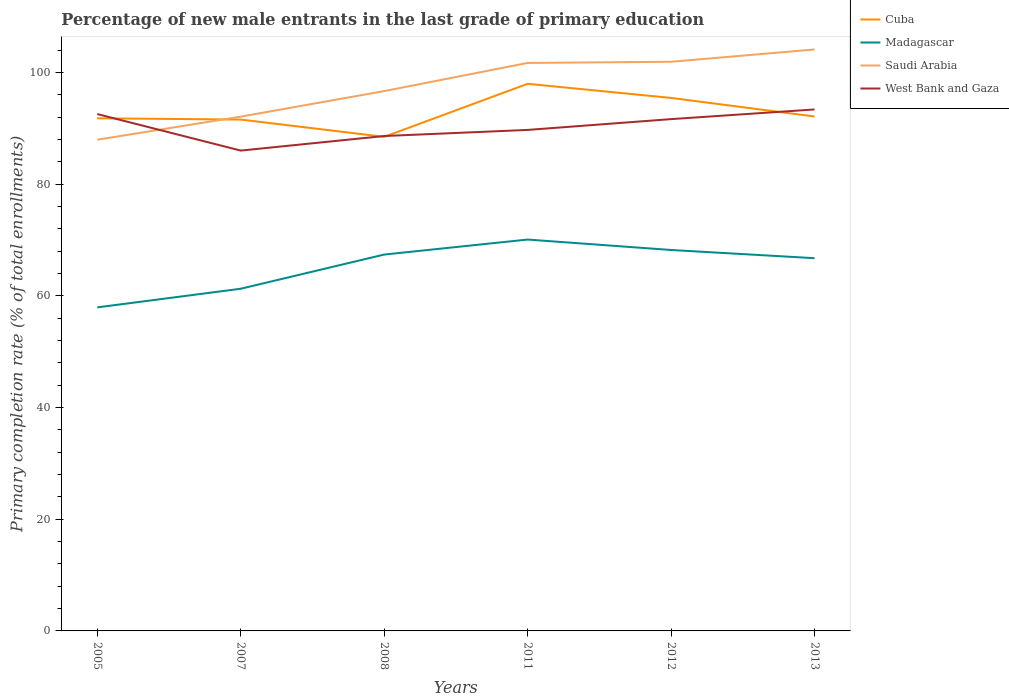Does the line corresponding to Madagascar intersect with the line corresponding to Cuba?
Provide a succinct answer. No. Across all years, what is the maximum percentage of new male entrants in West Bank and Gaza?
Ensure brevity in your answer.  86. In which year was the percentage of new male entrants in Cuba maximum?
Your answer should be very brief. 2008. What is the total percentage of new male entrants in West Bank and Gaza in the graph?
Make the answer very short. -0.83. What is the difference between the highest and the second highest percentage of new male entrants in Saudi Arabia?
Keep it short and to the point. 16.16. What is the difference between two consecutive major ticks on the Y-axis?
Give a very brief answer. 20. Are the values on the major ticks of Y-axis written in scientific E-notation?
Provide a short and direct response. No. Where does the legend appear in the graph?
Make the answer very short. Top right. How are the legend labels stacked?
Keep it short and to the point. Vertical. What is the title of the graph?
Provide a succinct answer. Percentage of new male entrants in the last grade of primary education. What is the label or title of the X-axis?
Your response must be concise. Years. What is the label or title of the Y-axis?
Keep it short and to the point. Primary completion rate (% of total enrollments). What is the Primary completion rate (% of total enrollments) in Cuba in 2005?
Keep it short and to the point. 91.78. What is the Primary completion rate (% of total enrollments) in Madagascar in 2005?
Keep it short and to the point. 57.92. What is the Primary completion rate (% of total enrollments) in Saudi Arabia in 2005?
Offer a terse response. 87.94. What is the Primary completion rate (% of total enrollments) in West Bank and Gaza in 2005?
Give a very brief answer. 92.54. What is the Primary completion rate (% of total enrollments) in Cuba in 2007?
Ensure brevity in your answer.  91.55. What is the Primary completion rate (% of total enrollments) of Madagascar in 2007?
Offer a terse response. 61.26. What is the Primary completion rate (% of total enrollments) in Saudi Arabia in 2007?
Ensure brevity in your answer.  92.07. What is the Primary completion rate (% of total enrollments) in West Bank and Gaza in 2007?
Ensure brevity in your answer.  86. What is the Primary completion rate (% of total enrollments) in Cuba in 2008?
Ensure brevity in your answer.  88.46. What is the Primary completion rate (% of total enrollments) of Madagascar in 2008?
Offer a terse response. 67.38. What is the Primary completion rate (% of total enrollments) in Saudi Arabia in 2008?
Your answer should be very brief. 96.65. What is the Primary completion rate (% of total enrollments) of West Bank and Gaza in 2008?
Make the answer very short. 88.6. What is the Primary completion rate (% of total enrollments) in Cuba in 2011?
Offer a terse response. 97.95. What is the Primary completion rate (% of total enrollments) of Madagascar in 2011?
Your answer should be compact. 70.07. What is the Primary completion rate (% of total enrollments) in Saudi Arabia in 2011?
Provide a short and direct response. 101.69. What is the Primary completion rate (% of total enrollments) of West Bank and Gaza in 2011?
Your answer should be very brief. 89.7. What is the Primary completion rate (% of total enrollments) in Cuba in 2012?
Offer a very short reply. 95.42. What is the Primary completion rate (% of total enrollments) in Madagascar in 2012?
Offer a very short reply. 68.2. What is the Primary completion rate (% of total enrollments) in Saudi Arabia in 2012?
Your answer should be compact. 101.9. What is the Primary completion rate (% of total enrollments) of West Bank and Gaza in 2012?
Your response must be concise. 91.63. What is the Primary completion rate (% of total enrollments) in Cuba in 2013?
Your answer should be very brief. 92.1. What is the Primary completion rate (% of total enrollments) of Madagascar in 2013?
Your response must be concise. 66.73. What is the Primary completion rate (% of total enrollments) in Saudi Arabia in 2013?
Provide a succinct answer. 104.1. What is the Primary completion rate (% of total enrollments) of West Bank and Gaza in 2013?
Your answer should be compact. 93.36. Across all years, what is the maximum Primary completion rate (% of total enrollments) in Cuba?
Provide a short and direct response. 97.95. Across all years, what is the maximum Primary completion rate (% of total enrollments) in Madagascar?
Give a very brief answer. 70.07. Across all years, what is the maximum Primary completion rate (% of total enrollments) in Saudi Arabia?
Keep it short and to the point. 104.1. Across all years, what is the maximum Primary completion rate (% of total enrollments) in West Bank and Gaza?
Your response must be concise. 93.36. Across all years, what is the minimum Primary completion rate (% of total enrollments) of Cuba?
Provide a succinct answer. 88.46. Across all years, what is the minimum Primary completion rate (% of total enrollments) in Madagascar?
Provide a succinct answer. 57.92. Across all years, what is the minimum Primary completion rate (% of total enrollments) in Saudi Arabia?
Keep it short and to the point. 87.94. Across all years, what is the minimum Primary completion rate (% of total enrollments) of West Bank and Gaza?
Provide a short and direct response. 86. What is the total Primary completion rate (% of total enrollments) in Cuba in the graph?
Make the answer very short. 557.26. What is the total Primary completion rate (% of total enrollments) of Madagascar in the graph?
Make the answer very short. 391.57. What is the total Primary completion rate (% of total enrollments) in Saudi Arabia in the graph?
Your answer should be compact. 584.34. What is the total Primary completion rate (% of total enrollments) of West Bank and Gaza in the graph?
Make the answer very short. 541.82. What is the difference between the Primary completion rate (% of total enrollments) of Cuba in 2005 and that in 2007?
Your answer should be very brief. 0.22. What is the difference between the Primary completion rate (% of total enrollments) in Madagascar in 2005 and that in 2007?
Offer a very short reply. -3.34. What is the difference between the Primary completion rate (% of total enrollments) of Saudi Arabia in 2005 and that in 2007?
Give a very brief answer. -4.13. What is the difference between the Primary completion rate (% of total enrollments) of West Bank and Gaza in 2005 and that in 2007?
Offer a terse response. 6.54. What is the difference between the Primary completion rate (% of total enrollments) of Cuba in 2005 and that in 2008?
Ensure brevity in your answer.  3.32. What is the difference between the Primary completion rate (% of total enrollments) of Madagascar in 2005 and that in 2008?
Give a very brief answer. -9.46. What is the difference between the Primary completion rate (% of total enrollments) in Saudi Arabia in 2005 and that in 2008?
Offer a terse response. -8.71. What is the difference between the Primary completion rate (% of total enrollments) of West Bank and Gaza in 2005 and that in 2008?
Ensure brevity in your answer.  3.93. What is the difference between the Primary completion rate (% of total enrollments) in Cuba in 2005 and that in 2011?
Offer a very short reply. -6.18. What is the difference between the Primary completion rate (% of total enrollments) in Madagascar in 2005 and that in 2011?
Make the answer very short. -12.14. What is the difference between the Primary completion rate (% of total enrollments) of Saudi Arabia in 2005 and that in 2011?
Offer a very short reply. -13.75. What is the difference between the Primary completion rate (% of total enrollments) of West Bank and Gaza in 2005 and that in 2011?
Make the answer very short. 2.84. What is the difference between the Primary completion rate (% of total enrollments) in Cuba in 2005 and that in 2012?
Make the answer very short. -3.65. What is the difference between the Primary completion rate (% of total enrollments) of Madagascar in 2005 and that in 2012?
Ensure brevity in your answer.  -10.28. What is the difference between the Primary completion rate (% of total enrollments) of Saudi Arabia in 2005 and that in 2012?
Offer a terse response. -13.96. What is the difference between the Primary completion rate (% of total enrollments) in West Bank and Gaza in 2005 and that in 2012?
Offer a very short reply. 0.91. What is the difference between the Primary completion rate (% of total enrollments) in Cuba in 2005 and that in 2013?
Ensure brevity in your answer.  -0.32. What is the difference between the Primary completion rate (% of total enrollments) of Madagascar in 2005 and that in 2013?
Provide a short and direct response. -8.81. What is the difference between the Primary completion rate (% of total enrollments) in Saudi Arabia in 2005 and that in 2013?
Make the answer very short. -16.16. What is the difference between the Primary completion rate (% of total enrollments) of West Bank and Gaza in 2005 and that in 2013?
Make the answer very short. -0.83. What is the difference between the Primary completion rate (% of total enrollments) of Cuba in 2007 and that in 2008?
Give a very brief answer. 3.09. What is the difference between the Primary completion rate (% of total enrollments) in Madagascar in 2007 and that in 2008?
Your response must be concise. -6.12. What is the difference between the Primary completion rate (% of total enrollments) of Saudi Arabia in 2007 and that in 2008?
Give a very brief answer. -4.57. What is the difference between the Primary completion rate (% of total enrollments) of West Bank and Gaza in 2007 and that in 2008?
Ensure brevity in your answer.  -2.61. What is the difference between the Primary completion rate (% of total enrollments) of Cuba in 2007 and that in 2011?
Your response must be concise. -6.4. What is the difference between the Primary completion rate (% of total enrollments) of Madagascar in 2007 and that in 2011?
Provide a succinct answer. -8.8. What is the difference between the Primary completion rate (% of total enrollments) of Saudi Arabia in 2007 and that in 2011?
Your answer should be compact. -9.61. What is the difference between the Primary completion rate (% of total enrollments) in West Bank and Gaza in 2007 and that in 2011?
Provide a short and direct response. -3.7. What is the difference between the Primary completion rate (% of total enrollments) of Cuba in 2007 and that in 2012?
Provide a short and direct response. -3.87. What is the difference between the Primary completion rate (% of total enrollments) of Madagascar in 2007 and that in 2012?
Provide a succinct answer. -6.94. What is the difference between the Primary completion rate (% of total enrollments) in Saudi Arabia in 2007 and that in 2012?
Your answer should be very brief. -9.82. What is the difference between the Primary completion rate (% of total enrollments) in West Bank and Gaza in 2007 and that in 2012?
Offer a very short reply. -5.63. What is the difference between the Primary completion rate (% of total enrollments) of Cuba in 2007 and that in 2013?
Provide a succinct answer. -0.55. What is the difference between the Primary completion rate (% of total enrollments) in Madagascar in 2007 and that in 2013?
Your answer should be compact. -5.47. What is the difference between the Primary completion rate (% of total enrollments) of Saudi Arabia in 2007 and that in 2013?
Make the answer very short. -12.03. What is the difference between the Primary completion rate (% of total enrollments) in West Bank and Gaza in 2007 and that in 2013?
Keep it short and to the point. -7.36. What is the difference between the Primary completion rate (% of total enrollments) of Cuba in 2008 and that in 2011?
Offer a terse response. -9.5. What is the difference between the Primary completion rate (% of total enrollments) in Madagascar in 2008 and that in 2011?
Provide a succinct answer. -2.69. What is the difference between the Primary completion rate (% of total enrollments) in Saudi Arabia in 2008 and that in 2011?
Provide a short and direct response. -5.04. What is the difference between the Primary completion rate (% of total enrollments) in West Bank and Gaza in 2008 and that in 2011?
Your answer should be very brief. -1.09. What is the difference between the Primary completion rate (% of total enrollments) in Cuba in 2008 and that in 2012?
Give a very brief answer. -6.97. What is the difference between the Primary completion rate (% of total enrollments) of Madagascar in 2008 and that in 2012?
Your answer should be compact. -0.82. What is the difference between the Primary completion rate (% of total enrollments) in Saudi Arabia in 2008 and that in 2012?
Provide a short and direct response. -5.25. What is the difference between the Primary completion rate (% of total enrollments) in West Bank and Gaza in 2008 and that in 2012?
Provide a short and direct response. -3.03. What is the difference between the Primary completion rate (% of total enrollments) of Cuba in 2008 and that in 2013?
Offer a terse response. -3.64. What is the difference between the Primary completion rate (% of total enrollments) in Madagascar in 2008 and that in 2013?
Offer a very short reply. 0.65. What is the difference between the Primary completion rate (% of total enrollments) in Saudi Arabia in 2008 and that in 2013?
Offer a very short reply. -7.45. What is the difference between the Primary completion rate (% of total enrollments) in West Bank and Gaza in 2008 and that in 2013?
Your response must be concise. -4.76. What is the difference between the Primary completion rate (% of total enrollments) of Cuba in 2011 and that in 2012?
Your answer should be compact. 2.53. What is the difference between the Primary completion rate (% of total enrollments) in Madagascar in 2011 and that in 2012?
Ensure brevity in your answer.  1.87. What is the difference between the Primary completion rate (% of total enrollments) of Saudi Arabia in 2011 and that in 2012?
Provide a short and direct response. -0.21. What is the difference between the Primary completion rate (% of total enrollments) in West Bank and Gaza in 2011 and that in 2012?
Give a very brief answer. -1.93. What is the difference between the Primary completion rate (% of total enrollments) of Cuba in 2011 and that in 2013?
Ensure brevity in your answer.  5.85. What is the difference between the Primary completion rate (% of total enrollments) in Madagascar in 2011 and that in 2013?
Your response must be concise. 3.33. What is the difference between the Primary completion rate (% of total enrollments) of Saudi Arabia in 2011 and that in 2013?
Provide a succinct answer. -2.41. What is the difference between the Primary completion rate (% of total enrollments) in West Bank and Gaza in 2011 and that in 2013?
Your answer should be very brief. -3.67. What is the difference between the Primary completion rate (% of total enrollments) in Cuba in 2012 and that in 2013?
Give a very brief answer. 3.32. What is the difference between the Primary completion rate (% of total enrollments) in Madagascar in 2012 and that in 2013?
Your response must be concise. 1.47. What is the difference between the Primary completion rate (% of total enrollments) of Saudi Arabia in 2012 and that in 2013?
Provide a succinct answer. -2.2. What is the difference between the Primary completion rate (% of total enrollments) of West Bank and Gaza in 2012 and that in 2013?
Give a very brief answer. -1.73. What is the difference between the Primary completion rate (% of total enrollments) in Cuba in 2005 and the Primary completion rate (% of total enrollments) in Madagascar in 2007?
Your answer should be very brief. 30.51. What is the difference between the Primary completion rate (% of total enrollments) of Cuba in 2005 and the Primary completion rate (% of total enrollments) of Saudi Arabia in 2007?
Your answer should be compact. -0.3. What is the difference between the Primary completion rate (% of total enrollments) of Cuba in 2005 and the Primary completion rate (% of total enrollments) of West Bank and Gaza in 2007?
Ensure brevity in your answer.  5.78. What is the difference between the Primary completion rate (% of total enrollments) in Madagascar in 2005 and the Primary completion rate (% of total enrollments) in Saudi Arabia in 2007?
Provide a short and direct response. -34.15. What is the difference between the Primary completion rate (% of total enrollments) of Madagascar in 2005 and the Primary completion rate (% of total enrollments) of West Bank and Gaza in 2007?
Keep it short and to the point. -28.07. What is the difference between the Primary completion rate (% of total enrollments) in Saudi Arabia in 2005 and the Primary completion rate (% of total enrollments) in West Bank and Gaza in 2007?
Give a very brief answer. 1.94. What is the difference between the Primary completion rate (% of total enrollments) of Cuba in 2005 and the Primary completion rate (% of total enrollments) of Madagascar in 2008?
Give a very brief answer. 24.39. What is the difference between the Primary completion rate (% of total enrollments) of Cuba in 2005 and the Primary completion rate (% of total enrollments) of Saudi Arabia in 2008?
Make the answer very short. -4.87. What is the difference between the Primary completion rate (% of total enrollments) in Cuba in 2005 and the Primary completion rate (% of total enrollments) in West Bank and Gaza in 2008?
Provide a succinct answer. 3.17. What is the difference between the Primary completion rate (% of total enrollments) of Madagascar in 2005 and the Primary completion rate (% of total enrollments) of Saudi Arabia in 2008?
Your answer should be compact. -38.72. What is the difference between the Primary completion rate (% of total enrollments) in Madagascar in 2005 and the Primary completion rate (% of total enrollments) in West Bank and Gaza in 2008?
Offer a very short reply. -30.68. What is the difference between the Primary completion rate (% of total enrollments) of Saudi Arabia in 2005 and the Primary completion rate (% of total enrollments) of West Bank and Gaza in 2008?
Keep it short and to the point. -0.67. What is the difference between the Primary completion rate (% of total enrollments) in Cuba in 2005 and the Primary completion rate (% of total enrollments) in Madagascar in 2011?
Your answer should be very brief. 21.71. What is the difference between the Primary completion rate (% of total enrollments) in Cuba in 2005 and the Primary completion rate (% of total enrollments) in Saudi Arabia in 2011?
Provide a succinct answer. -9.91. What is the difference between the Primary completion rate (% of total enrollments) of Cuba in 2005 and the Primary completion rate (% of total enrollments) of West Bank and Gaza in 2011?
Provide a succinct answer. 2.08. What is the difference between the Primary completion rate (% of total enrollments) of Madagascar in 2005 and the Primary completion rate (% of total enrollments) of Saudi Arabia in 2011?
Provide a short and direct response. -43.76. What is the difference between the Primary completion rate (% of total enrollments) of Madagascar in 2005 and the Primary completion rate (% of total enrollments) of West Bank and Gaza in 2011?
Your response must be concise. -31.77. What is the difference between the Primary completion rate (% of total enrollments) in Saudi Arabia in 2005 and the Primary completion rate (% of total enrollments) in West Bank and Gaza in 2011?
Keep it short and to the point. -1.76. What is the difference between the Primary completion rate (% of total enrollments) of Cuba in 2005 and the Primary completion rate (% of total enrollments) of Madagascar in 2012?
Provide a short and direct response. 23.57. What is the difference between the Primary completion rate (% of total enrollments) of Cuba in 2005 and the Primary completion rate (% of total enrollments) of Saudi Arabia in 2012?
Ensure brevity in your answer.  -10.12. What is the difference between the Primary completion rate (% of total enrollments) in Cuba in 2005 and the Primary completion rate (% of total enrollments) in West Bank and Gaza in 2012?
Make the answer very short. 0.15. What is the difference between the Primary completion rate (% of total enrollments) in Madagascar in 2005 and the Primary completion rate (% of total enrollments) in Saudi Arabia in 2012?
Your answer should be compact. -43.98. What is the difference between the Primary completion rate (% of total enrollments) of Madagascar in 2005 and the Primary completion rate (% of total enrollments) of West Bank and Gaza in 2012?
Ensure brevity in your answer.  -33.71. What is the difference between the Primary completion rate (% of total enrollments) of Saudi Arabia in 2005 and the Primary completion rate (% of total enrollments) of West Bank and Gaza in 2012?
Provide a succinct answer. -3.69. What is the difference between the Primary completion rate (% of total enrollments) of Cuba in 2005 and the Primary completion rate (% of total enrollments) of Madagascar in 2013?
Your answer should be very brief. 25.04. What is the difference between the Primary completion rate (% of total enrollments) of Cuba in 2005 and the Primary completion rate (% of total enrollments) of Saudi Arabia in 2013?
Keep it short and to the point. -12.32. What is the difference between the Primary completion rate (% of total enrollments) of Cuba in 2005 and the Primary completion rate (% of total enrollments) of West Bank and Gaza in 2013?
Keep it short and to the point. -1.59. What is the difference between the Primary completion rate (% of total enrollments) of Madagascar in 2005 and the Primary completion rate (% of total enrollments) of Saudi Arabia in 2013?
Give a very brief answer. -46.18. What is the difference between the Primary completion rate (% of total enrollments) of Madagascar in 2005 and the Primary completion rate (% of total enrollments) of West Bank and Gaza in 2013?
Keep it short and to the point. -35.44. What is the difference between the Primary completion rate (% of total enrollments) of Saudi Arabia in 2005 and the Primary completion rate (% of total enrollments) of West Bank and Gaza in 2013?
Provide a short and direct response. -5.42. What is the difference between the Primary completion rate (% of total enrollments) of Cuba in 2007 and the Primary completion rate (% of total enrollments) of Madagascar in 2008?
Keep it short and to the point. 24.17. What is the difference between the Primary completion rate (% of total enrollments) in Cuba in 2007 and the Primary completion rate (% of total enrollments) in Saudi Arabia in 2008?
Offer a very short reply. -5.09. What is the difference between the Primary completion rate (% of total enrollments) of Cuba in 2007 and the Primary completion rate (% of total enrollments) of West Bank and Gaza in 2008?
Provide a short and direct response. 2.95. What is the difference between the Primary completion rate (% of total enrollments) of Madagascar in 2007 and the Primary completion rate (% of total enrollments) of Saudi Arabia in 2008?
Your answer should be very brief. -35.38. What is the difference between the Primary completion rate (% of total enrollments) in Madagascar in 2007 and the Primary completion rate (% of total enrollments) in West Bank and Gaza in 2008?
Your answer should be very brief. -27.34. What is the difference between the Primary completion rate (% of total enrollments) of Saudi Arabia in 2007 and the Primary completion rate (% of total enrollments) of West Bank and Gaza in 2008?
Offer a very short reply. 3.47. What is the difference between the Primary completion rate (% of total enrollments) of Cuba in 2007 and the Primary completion rate (% of total enrollments) of Madagascar in 2011?
Your response must be concise. 21.48. What is the difference between the Primary completion rate (% of total enrollments) of Cuba in 2007 and the Primary completion rate (% of total enrollments) of Saudi Arabia in 2011?
Offer a terse response. -10.14. What is the difference between the Primary completion rate (% of total enrollments) in Cuba in 2007 and the Primary completion rate (% of total enrollments) in West Bank and Gaza in 2011?
Provide a short and direct response. 1.85. What is the difference between the Primary completion rate (% of total enrollments) in Madagascar in 2007 and the Primary completion rate (% of total enrollments) in Saudi Arabia in 2011?
Your response must be concise. -40.43. What is the difference between the Primary completion rate (% of total enrollments) of Madagascar in 2007 and the Primary completion rate (% of total enrollments) of West Bank and Gaza in 2011?
Make the answer very short. -28.43. What is the difference between the Primary completion rate (% of total enrollments) of Saudi Arabia in 2007 and the Primary completion rate (% of total enrollments) of West Bank and Gaza in 2011?
Give a very brief answer. 2.38. What is the difference between the Primary completion rate (% of total enrollments) in Cuba in 2007 and the Primary completion rate (% of total enrollments) in Madagascar in 2012?
Your response must be concise. 23.35. What is the difference between the Primary completion rate (% of total enrollments) in Cuba in 2007 and the Primary completion rate (% of total enrollments) in Saudi Arabia in 2012?
Keep it short and to the point. -10.35. What is the difference between the Primary completion rate (% of total enrollments) in Cuba in 2007 and the Primary completion rate (% of total enrollments) in West Bank and Gaza in 2012?
Your response must be concise. -0.08. What is the difference between the Primary completion rate (% of total enrollments) of Madagascar in 2007 and the Primary completion rate (% of total enrollments) of Saudi Arabia in 2012?
Ensure brevity in your answer.  -40.64. What is the difference between the Primary completion rate (% of total enrollments) in Madagascar in 2007 and the Primary completion rate (% of total enrollments) in West Bank and Gaza in 2012?
Provide a succinct answer. -30.37. What is the difference between the Primary completion rate (% of total enrollments) in Saudi Arabia in 2007 and the Primary completion rate (% of total enrollments) in West Bank and Gaza in 2012?
Make the answer very short. 0.44. What is the difference between the Primary completion rate (% of total enrollments) of Cuba in 2007 and the Primary completion rate (% of total enrollments) of Madagascar in 2013?
Provide a succinct answer. 24.82. What is the difference between the Primary completion rate (% of total enrollments) of Cuba in 2007 and the Primary completion rate (% of total enrollments) of Saudi Arabia in 2013?
Your answer should be very brief. -12.55. What is the difference between the Primary completion rate (% of total enrollments) of Cuba in 2007 and the Primary completion rate (% of total enrollments) of West Bank and Gaza in 2013?
Offer a very short reply. -1.81. What is the difference between the Primary completion rate (% of total enrollments) of Madagascar in 2007 and the Primary completion rate (% of total enrollments) of Saudi Arabia in 2013?
Provide a short and direct response. -42.84. What is the difference between the Primary completion rate (% of total enrollments) in Madagascar in 2007 and the Primary completion rate (% of total enrollments) in West Bank and Gaza in 2013?
Keep it short and to the point. -32.1. What is the difference between the Primary completion rate (% of total enrollments) in Saudi Arabia in 2007 and the Primary completion rate (% of total enrollments) in West Bank and Gaza in 2013?
Provide a succinct answer. -1.29. What is the difference between the Primary completion rate (% of total enrollments) in Cuba in 2008 and the Primary completion rate (% of total enrollments) in Madagascar in 2011?
Your answer should be very brief. 18.39. What is the difference between the Primary completion rate (% of total enrollments) of Cuba in 2008 and the Primary completion rate (% of total enrollments) of Saudi Arabia in 2011?
Your response must be concise. -13.23. What is the difference between the Primary completion rate (% of total enrollments) in Cuba in 2008 and the Primary completion rate (% of total enrollments) in West Bank and Gaza in 2011?
Give a very brief answer. -1.24. What is the difference between the Primary completion rate (% of total enrollments) in Madagascar in 2008 and the Primary completion rate (% of total enrollments) in Saudi Arabia in 2011?
Keep it short and to the point. -34.31. What is the difference between the Primary completion rate (% of total enrollments) of Madagascar in 2008 and the Primary completion rate (% of total enrollments) of West Bank and Gaza in 2011?
Provide a short and direct response. -22.31. What is the difference between the Primary completion rate (% of total enrollments) in Saudi Arabia in 2008 and the Primary completion rate (% of total enrollments) in West Bank and Gaza in 2011?
Your response must be concise. 6.95. What is the difference between the Primary completion rate (% of total enrollments) of Cuba in 2008 and the Primary completion rate (% of total enrollments) of Madagascar in 2012?
Give a very brief answer. 20.26. What is the difference between the Primary completion rate (% of total enrollments) in Cuba in 2008 and the Primary completion rate (% of total enrollments) in Saudi Arabia in 2012?
Your answer should be compact. -13.44. What is the difference between the Primary completion rate (% of total enrollments) of Cuba in 2008 and the Primary completion rate (% of total enrollments) of West Bank and Gaza in 2012?
Your response must be concise. -3.17. What is the difference between the Primary completion rate (% of total enrollments) of Madagascar in 2008 and the Primary completion rate (% of total enrollments) of Saudi Arabia in 2012?
Offer a very short reply. -34.52. What is the difference between the Primary completion rate (% of total enrollments) in Madagascar in 2008 and the Primary completion rate (% of total enrollments) in West Bank and Gaza in 2012?
Your answer should be compact. -24.25. What is the difference between the Primary completion rate (% of total enrollments) in Saudi Arabia in 2008 and the Primary completion rate (% of total enrollments) in West Bank and Gaza in 2012?
Offer a terse response. 5.02. What is the difference between the Primary completion rate (% of total enrollments) in Cuba in 2008 and the Primary completion rate (% of total enrollments) in Madagascar in 2013?
Ensure brevity in your answer.  21.72. What is the difference between the Primary completion rate (% of total enrollments) of Cuba in 2008 and the Primary completion rate (% of total enrollments) of Saudi Arabia in 2013?
Keep it short and to the point. -15.64. What is the difference between the Primary completion rate (% of total enrollments) in Cuba in 2008 and the Primary completion rate (% of total enrollments) in West Bank and Gaza in 2013?
Offer a very short reply. -4.91. What is the difference between the Primary completion rate (% of total enrollments) in Madagascar in 2008 and the Primary completion rate (% of total enrollments) in Saudi Arabia in 2013?
Provide a short and direct response. -36.72. What is the difference between the Primary completion rate (% of total enrollments) of Madagascar in 2008 and the Primary completion rate (% of total enrollments) of West Bank and Gaza in 2013?
Provide a succinct answer. -25.98. What is the difference between the Primary completion rate (% of total enrollments) in Saudi Arabia in 2008 and the Primary completion rate (% of total enrollments) in West Bank and Gaza in 2013?
Your response must be concise. 3.28. What is the difference between the Primary completion rate (% of total enrollments) in Cuba in 2011 and the Primary completion rate (% of total enrollments) in Madagascar in 2012?
Your answer should be very brief. 29.75. What is the difference between the Primary completion rate (% of total enrollments) in Cuba in 2011 and the Primary completion rate (% of total enrollments) in Saudi Arabia in 2012?
Make the answer very short. -3.95. What is the difference between the Primary completion rate (% of total enrollments) in Cuba in 2011 and the Primary completion rate (% of total enrollments) in West Bank and Gaza in 2012?
Make the answer very short. 6.32. What is the difference between the Primary completion rate (% of total enrollments) of Madagascar in 2011 and the Primary completion rate (% of total enrollments) of Saudi Arabia in 2012?
Your answer should be compact. -31.83. What is the difference between the Primary completion rate (% of total enrollments) in Madagascar in 2011 and the Primary completion rate (% of total enrollments) in West Bank and Gaza in 2012?
Your answer should be compact. -21.56. What is the difference between the Primary completion rate (% of total enrollments) in Saudi Arabia in 2011 and the Primary completion rate (% of total enrollments) in West Bank and Gaza in 2012?
Give a very brief answer. 10.06. What is the difference between the Primary completion rate (% of total enrollments) in Cuba in 2011 and the Primary completion rate (% of total enrollments) in Madagascar in 2013?
Make the answer very short. 31.22. What is the difference between the Primary completion rate (% of total enrollments) in Cuba in 2011 and the Primary completion rate (% of total enrollments) in Saudi Arabia in 2013?
Keep it short and to the point. -6.15. What is the difference between the Primary completion rate (% of total enrollments) of Cuba in 2011 and the Primary completion rate (% of total enrollments) of West Bank and Gaza in 2013?
Give a very brief answer. 4.59. What is the difference between the Primary completion rate (% of total enrollments) of Madagascar in 2011 and the Primary completion rate (% of total enrollments) of Saudi Arabia in 2013?
Your response must be concise. -34.03. What is the difference between the Primary completion rate (% of total enrollments) of Madagascar in 2011 and the Primary completion rate (% of total enrollments) of West Bank and Gaza in 2013?
Keep it short and to the point. -23.29. What is the difference between the Primary completion rate (% of total enrollments) in Saudi Arabia in 2011 and the Primary completion rate (% of total enrollments) in West Bank and Gaza in 2013?
Give a very brief answer. 8.33. What is the difference between the Primary completion rate (% of total enrollments) of Cuba in 2012 and the Primary completion rate (% of total enrollments) of Madagascar in 2013?
Keep it short and to the point. 28.69. What is the difference between the Primary completion rate (% of total enrollments) of Cuba in 2012 and the Primary completion rate (% of total enrollments) of Saudi Arabia in 2013?
Your response must be concise. -8.67. What is the difference between the Primary completion rate (% of total enrollments) in Cuba in 2012 and the Primary completion rate (% of total enrollments) in West Bank and Gaza in 2013?
Your response must be concise. 2.06. What is the difference between the Primary completion rate (% of total enrollments) of Madagascar in 2012 and the Primary completion rate (% of total enrollments) of Saudi Arabia in 2013?
Provide a succinct answer. -35.9. What is the difference between the Primary completion rate (% of total enrollments) of Madagascar in 2012 and the Primary completion rate (% of total enrollments) of West Bank and Gaza in 2013?
Your answer should be very brief. -25.16. What is the difference between the Primary completion rate (% of total enrollments) in Saudi Arabia in 2012 and the Primary completion rate (% of total enrollments) in West Bank and Gaza in 2013?
Provide a succinct answer. 8.54. What is the average Primary completion rate (% of total enrollments) of Cuba per year?
Offer a terse response. 92.88. What is the average Primary completion rate (% of total enrollments) in Madagascar per year?
Ensure brevity in your answer.  65.26. What is the average Primary completion rate (% of total enrollments) in Saudi Arabia per year?
Provide a short and direct response. 97.39. What is the average Primary completion rate (% of total enrollments) in West Bank and Gaza per year?
Your response must be concise. 90.3. In the year 2005, what is the difference between the Primary completion rate (% of total enrollments) in Cuba and Primary completion rate (% of total enrollments) in Madagascar?
Ensure brevity in your answer.  33.85. In the year 2005, what is the difference between the Primary completion rate (% of total enrollments) of Cuba and Primary completion rate (% of total enrollments) of Saudi Arabia?
Offer a terse response. 3.84. In the year 2005, what is the difference between the Primary completion rate (% of total enrollments) of Cuba and Primary completion rate (% of total enrollments) of West Bank and Gaza?
Ensure brevity in your answer.  -0.76. In the year 2005, what is the difference between the Primary completion rate (% of total enrollments) of Madagascar and Primary completion rate (% of total enrollments) of Saudi Arabia?
Ensure brevity in your answer.  -30.02. In the year 2005, what is the difference between the Primary completion rate (% of total enrollments) in Madagascar and Primary completion rate (% of total enrollments) in West Bank and Gaza?
Your answer should be very brief. -34.61. In the year 2005, what is the difference between the Primary completion rate (% of total enrollments) of Saudi Arabia and Primary completion rate (% of total enrollments) of West Bank and Gaza?
Your response must be concise. -4.6. In the year 2007, what is the difference between the Primary completion rate (% of total enrollments) of Cuba and Primary completion rate (% of total enrollments) of Madagascar?
Provide a succinct answer. 30.29. In the year 2007, what is the difference between the Primary completion rate (% of total enrollments) of Cuba and Primary completion rate (% of total enrollments) of Saudi Arabia?
Keep it short and to the point. -0.52. In the year 2007, what is the difference between the Primary completion rate (% of total enrollments) of Cuba and Primary completion rate (% of total enrollments) of West Bank and Gaza?
Make the answer very short. 5.55. In the year 2007, what is the difference between the Primary completion rate (% of total enrollments) of Madagascar and Primary completion rate (% of total enrollments) of Saudi Arabia?
Offer a very short reply. -30.81. In the year 2007, what is the difference between the Primary completion rate (% of total enrollments) in Madagascar and Primary completion rate (% of total enrollments) in West Bank and Gaza?
Keep it short and to the point. -24.74. In the year 2007, what is the difference between the Primary completion rate (% of total enrollments) of Saudi Arabia and Primary completion rate (% of total enrollments) of West Bank and Gaza?
Your answer should be very brief. 6.08. In the year 2008, what is the difference between the Primary completion rate (% of total enrollments) of Cuba and Primary completion rate (% of total enrollments) of Madagascar?
Provide a succinct answer. 21.07. In the year 2008, what is the difference between the Primary completion rate (% of total enrollments) in Cuba and Primary completion rate (% of total enrollments) in Saudi Arabia?
Your answer should be compact. -8.19. In the year 2008, what is the difference between the Primary completion rate (% of total enrollments) in Cuba and Primary completion rate (% of total enrollments) in West Bank and Gaza?
Your answer should be compact. -0.15. In the year 2008, what is the difference between the Primary completion rate (% of total enrollments) in Madagascar and Primary completion rate (% of total enrollments) in Saudi Arabia?
Offer a very short reply. -29.26. In the year 2008, what is the difference between the Primary completion rate (% of total enrollments) in Madagascar and Primary completion rate (% of total enrollments) in West Bank and Gaza?
Make the answer very short. -21.22. In the year 2008, what is the difference between the Primary completion rate (% of total enrollments) in Saudi Arabia and Primary completion rate (% of total enrollments) in West Bank and Gaza?
Make the answer very short. 8.04. In the year 2011, what is the difference between the Primary completion rate (% of total enrollments) in Cuba and Primary completion rate (% of total enrollments) in Madagascar?
Keep it short and to the point. 27.89. In the year 2011, what is the difference between the Primary completion rate (% of total enrollments) of Cuba and Primary completion rate (% of total enrollments) of Saudi Arabia?
Provide a succinct answer. -3.74. In the year 2011, what is the difference between the Primary completion rate (% of total enrollments) of Cuba and Primary completion rate (% of total enrollments) of West Bank and Gaza?
Ensure brevity in your answer.  8.26. In the year 2011, what is the difference between the Primary completion rate (% of total enrollments) in Madagascar and Primary completion rate (% of total enrollments) in Saudi Arabia?
Your answer should be compact. -31.62. In the year 2011, what is the difference between the Primary completion rate (% of total enrollments) of Madagascar and Primary completion rate (% of total enrollments) of West Bank and Gaza?
Provide a short and direct response. -19.63. In the year 2011, what is the difference between the Primary completion rate (% of total enrollments) in Saudi Arabia and Primary completion rate (% of total enrollments) in West Bank and Gaza?
Your response must be concise. 11.99. In the year 2012, what is the difference between the Primary completion rate (% of total enrollments) of Cuba and Primary completion rate (% of total enrollments) of Madagascar?
Your answer should be compact. 27.22. In the year 2012, what is the difference between the Primary completion rate (% of total enrollments) in Cuba and Primary completion rate (% of total enrollments) in Saudi Arabia?
Offer a terse response. -6.47. In the year 2012, what is the difference between the Primary completion rate (% of total enrollments) in Cuba and Primary completion rate (% of total enrollments) in West Bank and Gaza?
Your answer should be compact. 3.79. In the year 2012, what is the difference between the Primary completion rate (% of total enrollments) of Madagascar and Primary completion rate (% of total enrollments) of Saudi Arabia?
Provide a short and direct response. -33.7. In the year 2012, what is the difference between the Primary completion rate (% of total enrollments) of Madagascar and Primary completion rate (% of total enrollments) of West Bank and Gaza?
Provide a short and direct response. -23.43. In the year 2012, what is the difference between the Primary completion rate (% of total enrollments) of Saudi Arabia and Primary completion rate (% of total enrollments) of West Bank and Gaza?
Your response must be concise. 10.27. In the year 2013, what is the difference between the Primary completion rate (% of total enrollments) in Cuba and Primary completion rate (% of total enrollments) in Madagascar?
Ensure brevity in your answer.  25.37. In the year 2013, what is the difference between the Primary completion rate (% of total enrollments) in Cuba and Primary completion rate (% of total enrollments) in Saudi Arabia?
Provide a short and direct response. -12. In the year 2013, what is the difference between the Primary completion rate (% of total enrollments) of Cuba and Primary completion rate (% of total enrollments) of West Bank and Gaza?
Give a very brief answer. -1.26. In the year 2013, what is the difference between the Primary completion rate (% of total enrollments) of Madagascar and Primary completion rate (% of total enrollments) of Saudi Arabia?
Offer a very short reply. -37.37. In the year 2013, what is the difference between the Primary completion rate (% of total enrollments) of Madagascar and Primary completion rate (% of total enrollments) of West Bank and Gaza?
Your answer should be very brief. -26.63. In the year 2013, what is the difference between the Primary completion rate (% of total enrollments) of Saudi Arabia and Primary completion rate (% of total enrollments) of West Bank and Gaza?
Your response must be concise. 10.74. What is the ratio of the Primary completion rate (% of total enrollments) of Madagascar in 2005 to that in 2007?
Keep it short and to the point. 0.95. What is the ratio of the Primary completion rate (% of total enrollments) of Saudi Arabia in 2005 to that in 2007?
Make the answer very short. 0.96. What is the ratio of the Primary completion rate (% of total enrollments) in West Bank and Gaza in 2005 to that in 2007?
Provide a succinct answer. 1.08. What is the ratio of the Primary completion rate (% of total enrollments) in Cuba in 2005 to that in 2008?
Provide a short and direct response. 1.04. What is the ratio of the Primary completion rate (% of total enrollments) of Madagascar in 2005 to that in 2008?
Offer a terse response. 0.86. What is the ratio of the Primary completion rate (% of total enrollments) of Saudi Arabia in 2005 to that in 2008?
Offer a very short reply. 0.91. What is the ratio of the Primary completion rate (% of total enrollments) in West Bank and Gaza in 2005 to that in 2008?
Your response must be concise. 1.04. What is the ratio of the Primary completion rate (% of total enrollments) in Cuba in 2005 to that in 2011?
Make the answer very short. 0.94. What is the ratio of the Primary completion rate (% of total enrollments) of Madagascar in 2005 to that in 2011?
Offer a terse response. 0.83. What is the ratio of the Primary completion rate (% of total enrollments) of Saudi Arabia in 2005 to that in 2011?
Offer a very short reply. 0.86. What is the ratio of the Primary completion rate (% of total enrollments) in West Bank and Gaza in 2005 to that in 2011?
Your answer should be compact. 1.03. What is the ratio of the Primary completion rate (% of total enrollments) of Cuba in 2005 to that in 2012?
Offer a very short reply. 0.96. What is the ratio of the Primary completion rate (% of total enrollments) of Madagascar in 2005 to that in 2012?
Provide a succinct answer. 0.85. What is the ratio of the Primary completion rate (% of total enrollments) in Saudi Arabia in 2005 to that in 2012?
Your answer should be very brief. 0.86. What is the ratio of the Primary completion rate (% of total enrollments) of West Bank and Gaza in 2005 to that in 2012?
Offer a terse response. 1.01. What is the ratio of the Primary completion rate (% of total enrollments) in Cuba in 2005 to that in 2013?
Your answer should be compact. 1. What is the ratio of the Primary completion rate (% of total enrollments) of Madagascar in 2005 to that in 2013?
Provide a short and direct response. 0.87. What is the ratio of the Primary completion rate (% of total enrollments) of Saudi Arabia in 2005 to that in 2013?
Provide a short and direct response. 0.84. What is the ratio of the Primary completion rate (% of total enrollments) in West Bank and Gaza in 2005 to that in 2013?
Provide a short and direct response. 0.99. What is the ratio of the Primary completion rate (% of total enrollments) of Cuba in 2007 to that in 2008?
Give a very brief answer. 1.03. What is the ratio of the Primary completion rate (% of total enrollments) in Madagascar in 2007 to that in 2008?
Keep it short and to the point. 0.91. What is the ratio of the Primary completion rate (% of total enrollments) of Saudi Arabia in 2007 to that in 2008?
Your answer should be very brief. 0.95. What is the ratio of the Primary completion rate (% of total enrollments) in West Bank and Gaza in 2007 to that in 2008?
Provide a succinct answer. 0.97. What is the ratio of the Primary completion rate (% of total enrollments) of Cuba in 2007 to that in 2011?
Provide a succinct answer. 0.93. What is the ratio of the Primary completion rate (% of total enrollments) in Madagascar in 2007 to that in 2011?
Your response must be concise. 0.87. What is the ratio of the Primary completion rate (% of total enrollments) of Saudi Arabia in 2007 to that in 2011?
Offer a very short reply. 0.91. What is the ratio of the Primary completion rate (% of total enrollments) of West Bank and Gaza in 2007 to that in 2011?
Your answer should be very brief. 0.96. What is the ratio of the Primary completion rate (% of total enrollments) of Cuba in 2007 to that in 2012?
Make the answer very short. 0.96. What is the ratio of the Primary completion rate (% of total enrollments) of Madagascar in 2007 to that in 2012?
Your answer should be very brief. 0.9. What is the ratio of the Primary completion rate (% of total enrollments) of Saudi Arabia in 2007 to that in 2012?
Ensure brevity in your answer.  0.9. What is the ratio of the Primary completion rate (% of total enrollments) of West Bank and Gaza in 2007 to that in 2012?
Provide a short and direct response. 0.94. What is the ratio of the Primary completion rate (% of total enrollments) in Cuba in 2007 to that in 2013?
Make the answer very short. 0.99. What is the ratio of the Primary completion rate (% of total enrollments) of Madagascar in 2007 to that in 2013?
Provide a short and direct response. 0.92. What is the ratio of the Primary completion rate (% of total enrollments) in Saudi Arabia in 2007 to that in 2013?
Your answer should be very brief. 0.88. What is the ratio of the Primary completion rate (% of total enrollments) of West Bank and Gaza in 2007 to that in 2013?
Keep it short and to the point. 0.92. What is the ratio of the Primary completion rate (% of total enrollments) of Cuba in 2008 to that in 2011?
Ensure brevity in your answer.  0.9. What is the ratio of the Primary completion rate (% of total enrollments) of Madagascar in 2008 to that in 2011?
Make the answer very short. 0.96. What is the ratio of the Primary completion rate (% of total enrollments) in Saudi Arabia in 2008 to that in 2011?
Give a very brief answer. 0.95. What is the ratio of the Primary completion rate (% of total enrollments) of Cuba in 2008 to that in 2012?
Keep it short and to the point. 0.93. What is the ratio of the Primary completion rate (% of total enrollments) of Saudi Arabia in 2008 to that in 2012?
Provide a succinct answer. 0.95. What is the ratio of the Primary completion rate (% of total enrollments) of West Bank and Gaza in 2008 to that in 2012?
Keep it short and to the point. 0.97. What is the ratio of the Primary completion rate (% of total enrollments) in Cuba in 2008 to that in 2013?
Your response must be concise. 0.96. What is the ratio of the Primary completion rate (% of total enrollments) of Madagascar in 2008 to that in 2013?
Offer a terse response. 1.01. What is the ratio of the Primary completion rate (% of total enrollments) of Saudi Arabia in 2008 to that in 2013?
Provide a succinct answer. 0.93. What is the ratio of the Primary completion rate (% of total enrollments) of West Bank and Gaza in 2008 to that in 2013?
Your answer should be compact. 0.95. What is the ratio of the Primary completion rate (% of total enrollments) of Cuba in 2011 to that in 2012?
Your answer should be very brief. 1.03. What is the ratio of the Primary completion rate (% of total enrollments) in Madagascar in 2011 to that in 2012?
Provide a succinct answer. 1.03. What is the ratio of the Primary completion rate (% of total enrollments) of Saudi Arabia in 2011 to that in 2012?
Give a very brief answer. 1. What is the ratio of the Primary completion rate (% of total enrollments) of West Bank and Gaza in 2011 to that in 2012?
Give a very brief answer. 0.98. What is the ratio of the Primary completion rate (% of total enrollments) of Cuba in 2011 to that in 2013?
Your response must be concise. 1.06. What is the ratio of the Primary completion rate (% of total enrollments) of Madagascar in 2011 to that in 2013?
Provide a short and direct response. 1.05. What is the ratio of the Primary completion rate (% of total enrollments) of Saudi Arabia in 2011 to that in 2013?
Your answer should be very brief. 0.98. What is the ratio of the Primary completion rate (% of total enrollments) of West Bank and Gaza in 2011 to that in 2013?
Your answer should be very brief. 0.96. What is the ratio of the Primary completion rate (% of total enrollments) of Cuba in 2012 to that in 2013?
Make the answer very short. 1.04. What is the ratio of the Primary completion rate (% of total enrollments) in Saudi Arabia in 2012 to that in 2013?
Provide a short and direct response. 0.98. What is the ratio of the Primary completion rate (% of total enrollments) in West Bank and Gaza in 2012 to that in 2013?
Your answer should be compact. 0.98. What is the difference between the highest and the second highest Primary completion rate (% of total enrollments) of Cuba?
Your answer should be very brief. 2.53. What is the difference between the highest and the second highest Primary completion rate (% of total enrollments) of Madagascar?
Provide a succinct answer. 1.87. What is the difference between the highest and the second highest Primary completion rate (% of total enrollments) of Saudi Arabia?
Your answer should be very brief. 2.2. What is the difference between the highest and the second highest Primary completion rate (% of total enrollments) of West Bank and Gaza?
Your answer should be very brief. 0.83. What is the difference between the highest and the lowest Primary completion rate (% of total enrollments) of Cuba?
Your answer should be very brief. 9.5. What is the difference between the highest and the lowest Primary completion rate (% of total enrollments) in Madagascar?
Provide a succinct answer. 12.14. What is the difference between the highest and the lowest Primary completion rate (% of total enrollments) of Saudi Arabia?
Keep it short and to the point. 16.16. What is the difference between the highest and the lowest Primary completion rate (% of total enrollments) of West Bank and Gaza?
Offer a terse response. 7.36. 